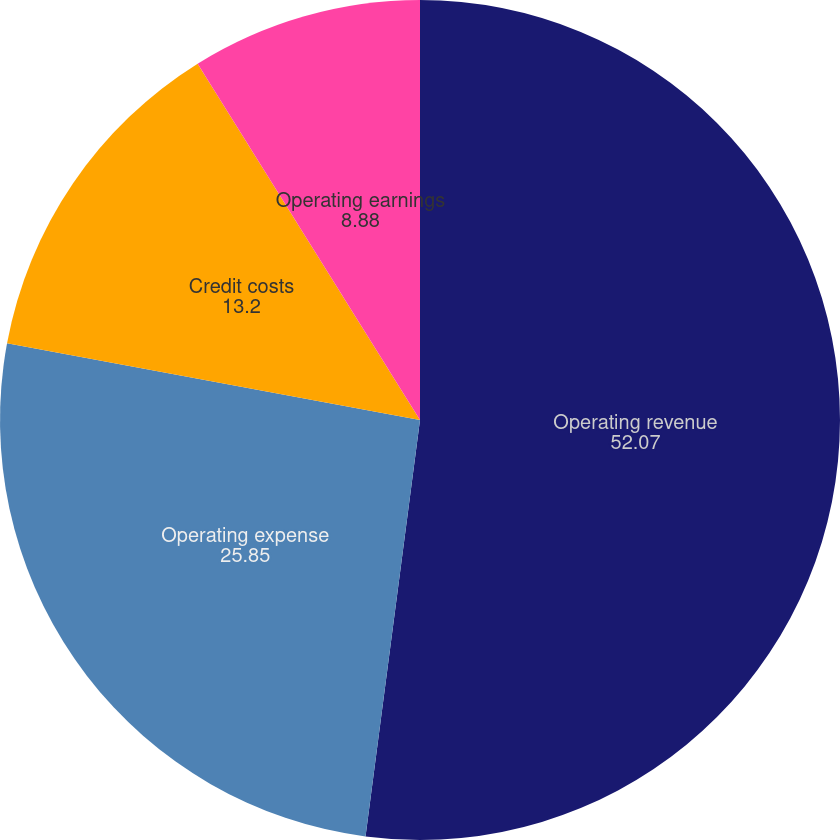<chart> <loc_0><loc_0><loc_500><loc_500><pie_chart><fcel>Operating revenue<fcel>Operating expense<fcel>Credit costs<fcel>Operating earnings<nl><fcel>52.07%<fcel>25.85%<fcel>13.2%<fcel>8.88%<nl></chart> 